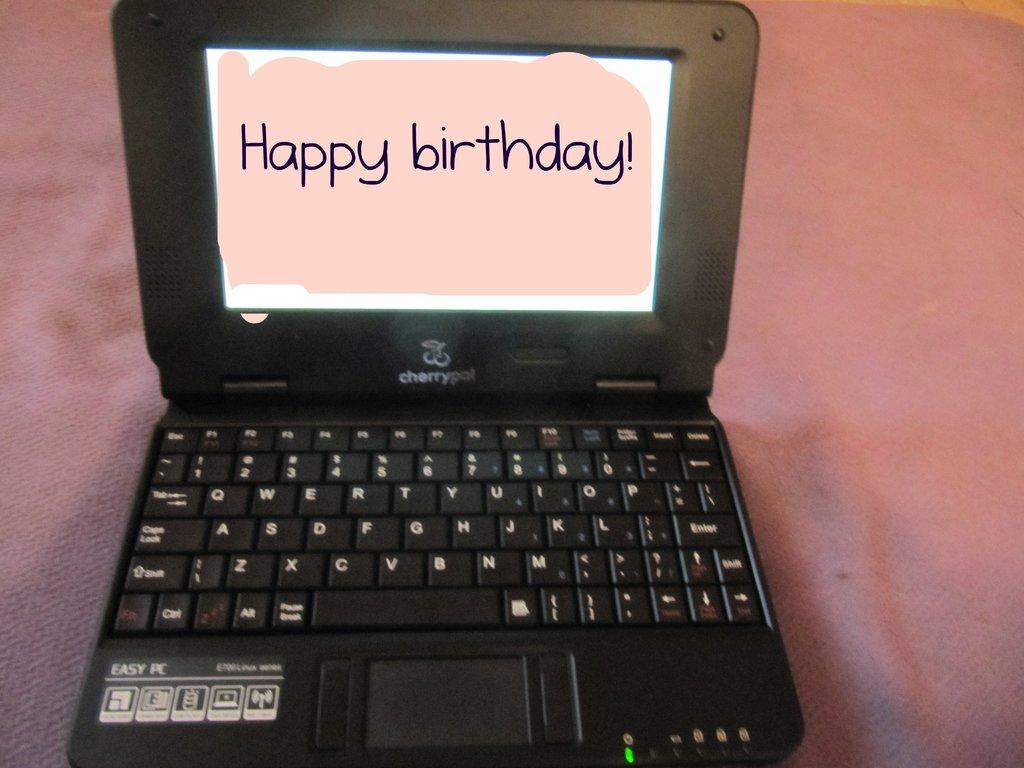<image>
Give a short and clear explanation of the subsequent image. A small laptop displays the message Happy birthday on the screen. 